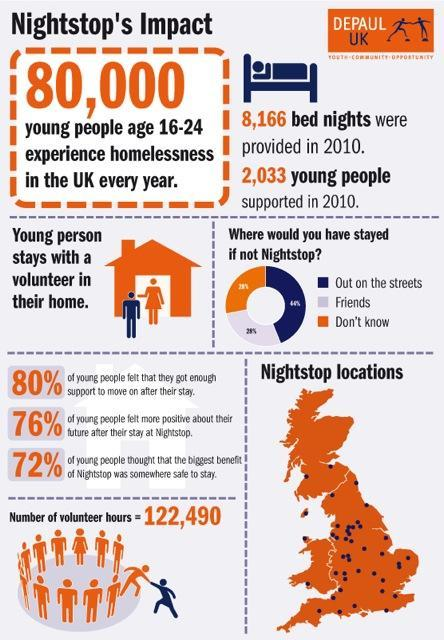Where would most number of people would have stayed if not Nightstop?
Answer the question with a short phrase. Out on the streets 